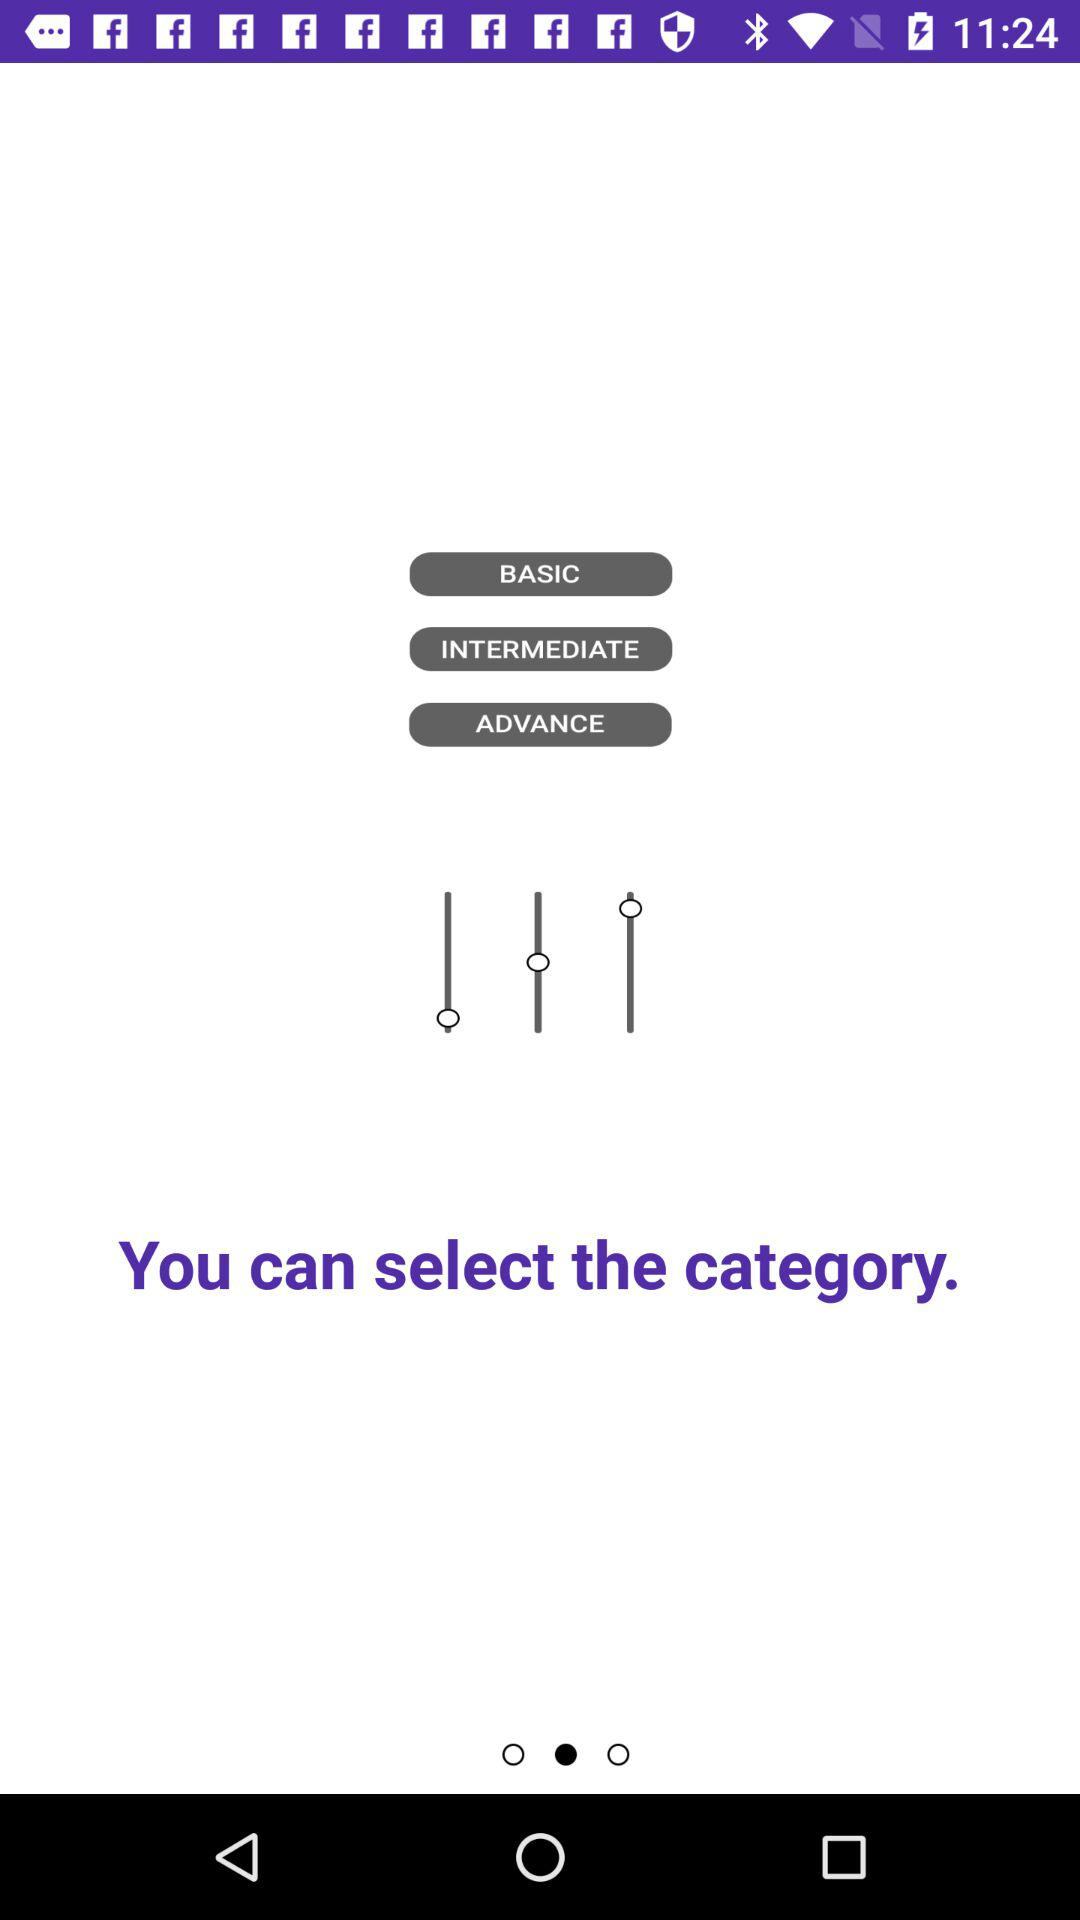What are the different categories to be selected? The different categories are "BASIC", "INTERMEDIATE", and "ADVANCE". 